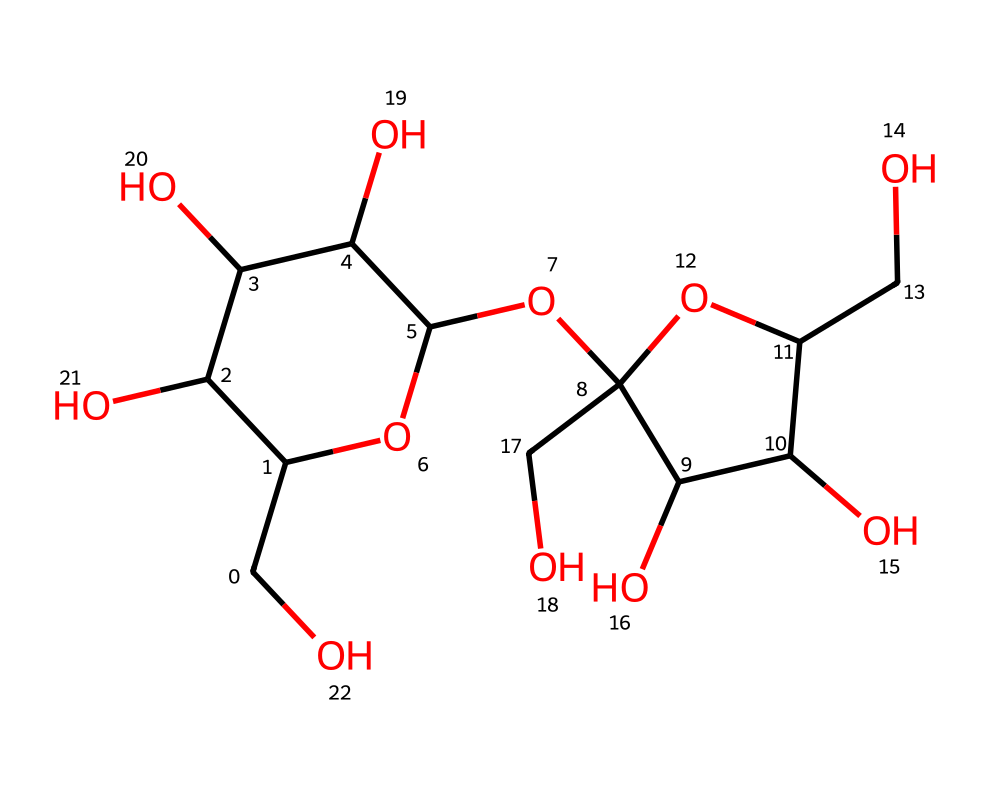What is the molecular formula of this compound? To find the molecular formula, we count the number of carbon (C), hydrogen (H), and oxygen (O) atoms present in the structure. The counts show that there are 12 carbon atoms, 22 hydrogen atoms, and 11 oxygen atoms, giving us the formula C12H22O11.
Answer: C12H22O11 How many rings are present in this structure? By examining the structure, it is evident that there are two cyclic portions in the molecule, indicating the presence of two ring structures.
Answer: 2 What type of carbohydrate is sucrose? Sucrose is a disaccharide, which means it is composed of two monosaccharide units (glucose and fructose) linked together. This categorization is based on its structure.
Answer: disaccharide What is the significance of the -OH groups in sucrose? The -OH groups represent hydroxyl functional groups, which are characteristic of sugars and play a key role in forming hydrogen bonds with water and other molecules, contributing to sucrose's solubility and sweetness.
Answer: solubility How many total hydroxyl groups are in this compound? By examining the structure closely, we can count the -OH (hydroxyl) groups present in the molecule. There are 11 -OH groups in total.
Answer: 11 Is this molecule sweet in taste? Yes, sucrose is known for its sweet taste, which is primarily due to its specific molecular structure that interacts with taste receptors.
Answer: yes 